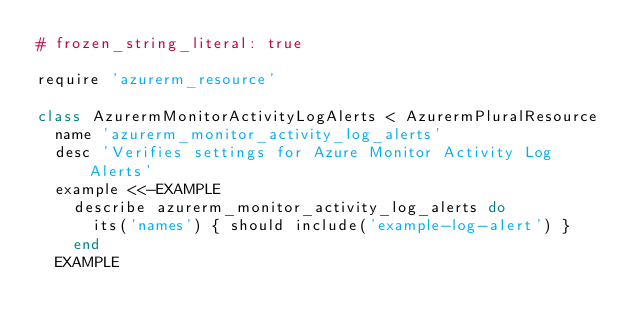<code> <loc_0><loc_0><loc_500><loc_500><_Ruby_># frozen_string_literal: true

require 'azurerm_resource'

class AzurermMonitorActivityLogAlerts < AzurermPluralResource
  name 'azurerm_monitor_activity_log_alerts'
  desc 'Verifies settings for Azure Monitor Activity Log Alerts'
  example <<-EXAMPLE
    describe azurerm_monitor_activity_log_alerts do
      its('names') { should include('example-log-alert') }
    end
  EXAMPLE
</code> 